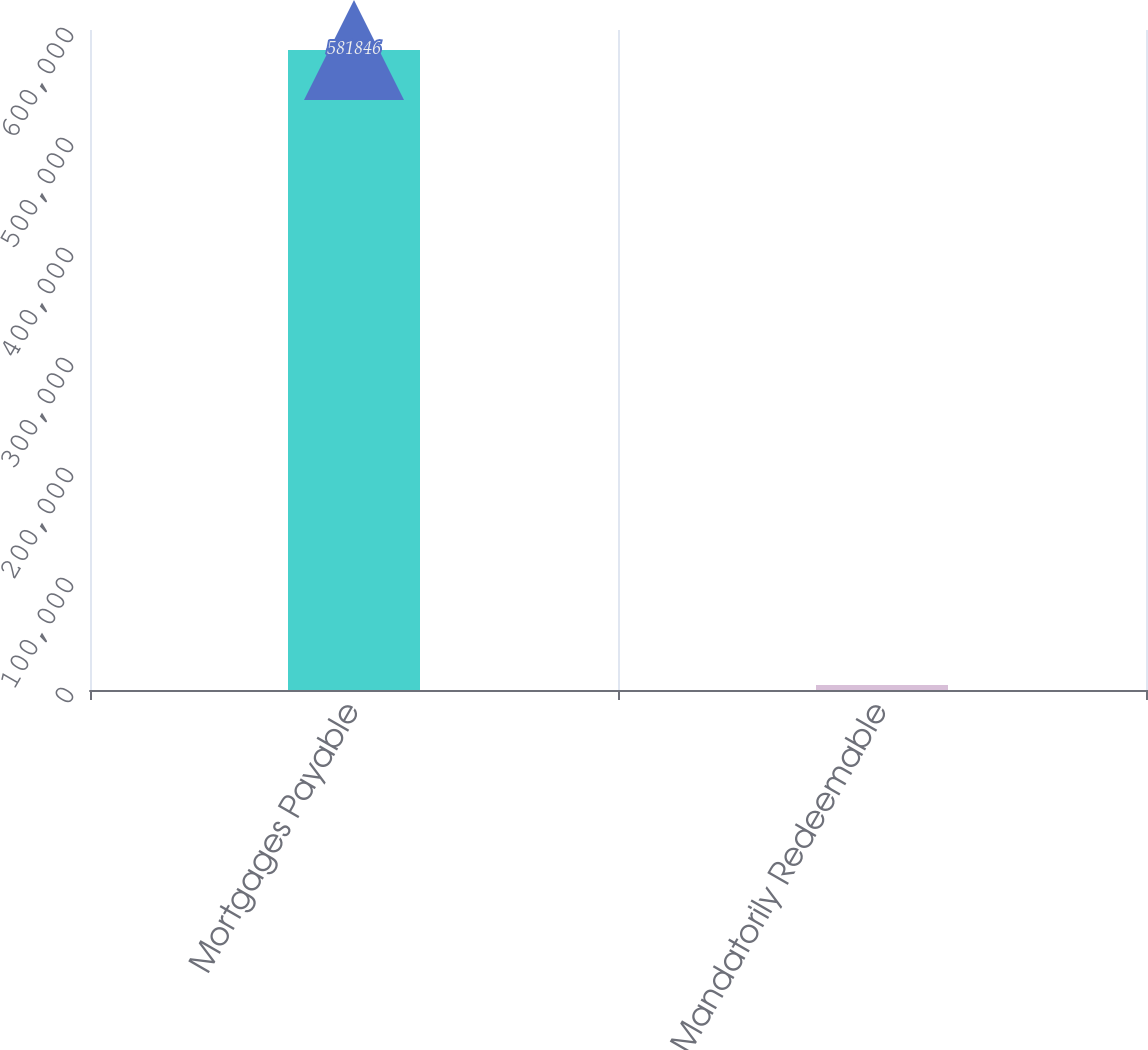Convert chart to OTSL. <chart><loc_0><loc_0><loc_500><loc_500><bar_chart><fcel>Mortgages Payable<fcel>Mandatorily Redeemable<nl><fcel>581846<fcel>4436<nl></chart> 